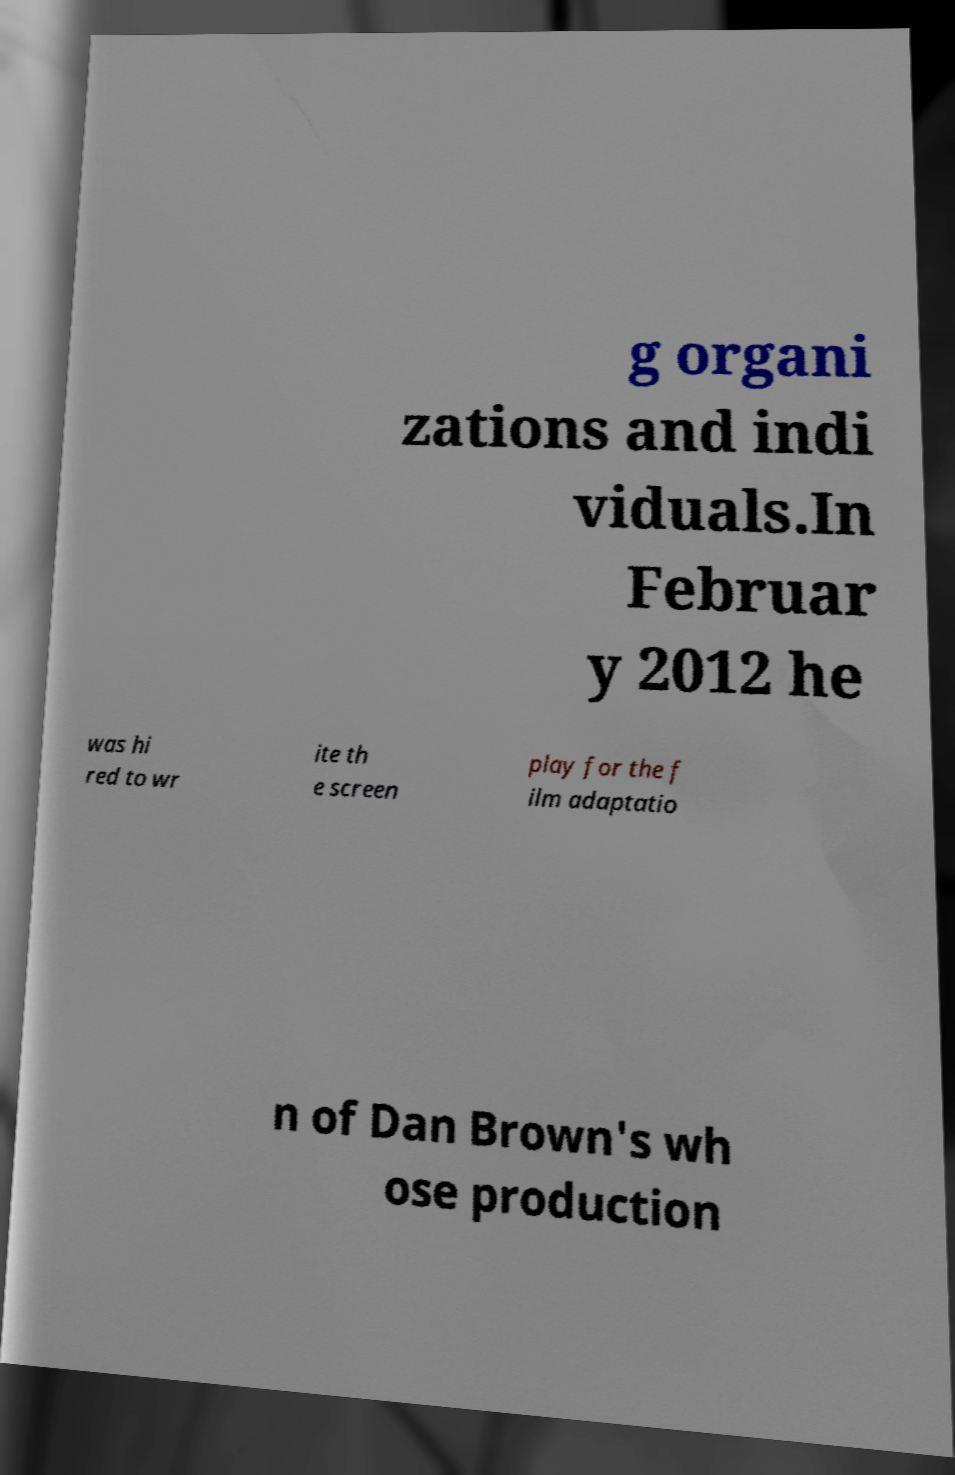Can you read and provide the text displayed in the image?This photo seems to have some interesting text. Can you extract and type it out for me? g organi zations and indi viduals.In Februar y 2012 he was hi red to wr ite th e screen play for the f ilm adaptatio n of Dan Brown's wh ose production 